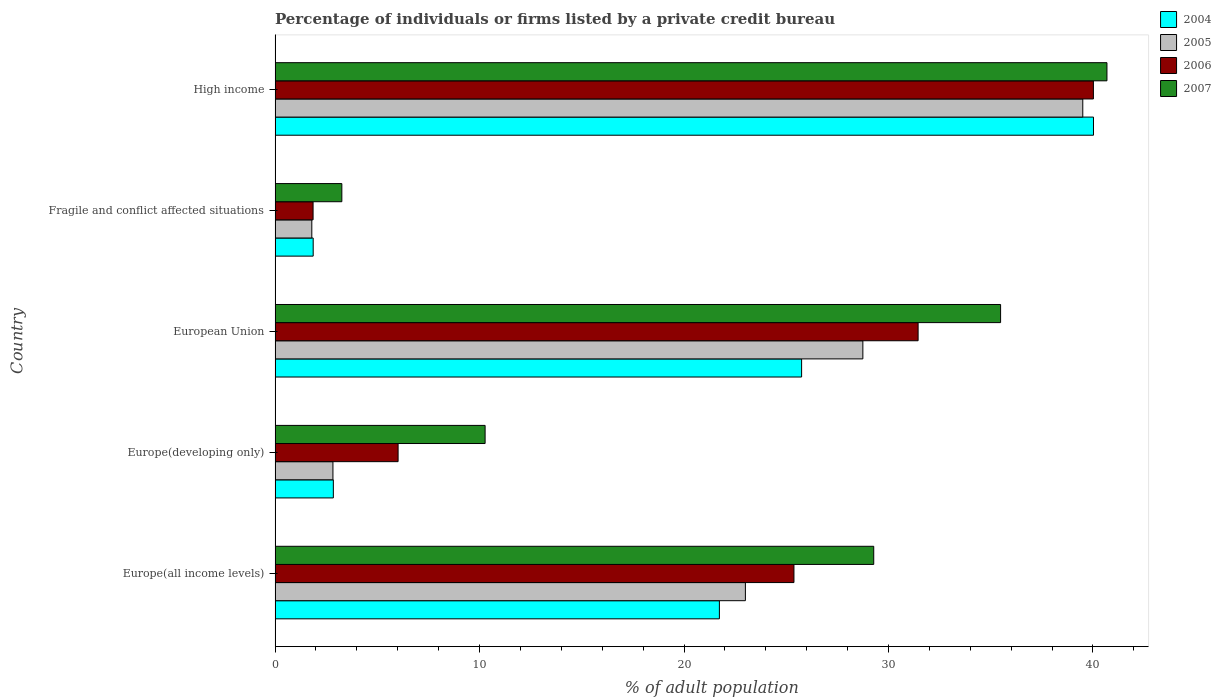Are the number of bars per tick equal to the number of legend labels?
Offer a very short reply. Yes. Are the number of bars on each tick of the Y-axis equal?
Offer a terse response. Yes. How many bars are there on the 5th tick from the bottom?
Provide a succinct answer. 4. In how many cases, is the number of bars for a given country not equal to the number of legend labels?
Your response must be concise. 0. What is the percentage of population listed by a private credit bureau in 2007 in European Union?
Your response must be concise. 35.48. Across all countries, what is the maximum percentage of population listed by a private credit bureau in 2006?
Offer a very short reply. 40.02. Across all countries, what is the minimum percentage of population listed by a private credit bureau in 2005?
Offer a very short reply. 1.8. In which country was the percentage of population listed by a private credit bureau in 2006 maximum?
Make the answer very short. High income. In which country was the percentage of population listed by a private credit bureau in 2004 minimum?
Keep it short and to the point. Fragile and conflict affected situations. What is the total percentage of population listed by a private credit bureau in 2004 in the graph?
Keep it short and to the point. 92.22. What is the difference between the percentage of population listed by a private credit bureau in 2005 in Europe(all income levels) and that in European Union?
Give a very brief answer. -5.75. What is the difference between the percentage of population listed by a private credit bureau in 2007 in Europe(developing only) and the percentage of population listed by a private credit bureau in 2005 in European Union?
Offer a very short reply. -18.48. What is the average percentage of population listed by a private credit bureau in 2004 per country?
Provide a succinct answer. 18.44. What is the difference between the percentage of population listed by a private credit bureau in 2004 and percentage of population listed by a private credit bureau in 2007 in Europe(all income levels)?
Make the answer very short. -7.55. In how many countries, is the percentage of population listed by a private credit bureau in 2004 greater than 18 %?
Offer a very short reply. 3. What is the ratio of the percentage of population listed by a private credit bureau in 2006 in Europe(developing only) to that in Fragile and conflict affected situations?
Your response must be concise. 3.24. What is the difference between the highest and the second highest percentage of population listed by a private credit bureau in 2006?
Ensure brevity in your answer.  8.57. What is the difference between the highest and the lowest percentage of population listed by a private credit bureau in 2006?
Offer a very short reply. 38.17. In how many countries, is the percentage of population listed by a private credit bureau in 2004 greater than the average percentage of population listed by a private credit bureau in 2004 taken over all countries?
Give a very brief answer. 3. Is the sum of the percentage of population listed by a private credit bureau in 2007 in Europe(all income levels) and Fragile and conflict affected situations greater than the maximum percentage of population listed by a private credit bureau in 2004 across all countries?
Your answer should be compact. No. What is the difference between two consecutive major ticks on the X-axis?
Give a very brief answer. 10. Does the graph contain grids?
Give a very brief answer. No. Where does the legend appear in the graph?
Make the answer very short. Top right. How many legend labels are there?
Your answer should be compact. 4. What is the title of the graph?
Provide a short and direct response. Percentage of individuals or firms listed by a private credit bureau. What is the label or title of the X-axis?
Ensure brevity in your answer.  % of adult population. What is the label or title of the Y-axis?
Your response must be concise. Country. What is the % of adult population of 2004 in Europe(all income levels)?
Make the answer very short. 21.73. What is the % of adult population of 2005 in Europe(all income levels)?
Make the answer very short. 23. What is the % of adult population of 2006 in Europe(all income levels)?
Give a very brief answer. 25.38. What is the % of adult population in 2007 in Europe(all income levels)?
Your answer should be compact. 29.28. What is the % of adult population of 2004 in Europe(developing only)?
Give a very brief answer. 2.85. What is the % of adult population in 2005 in Europe(developing only)?
Make the answer very short. 2.83. What is the % of adult population in 2006 in Europe(developing only)?
Offer a terse response. 6.02. What is the % of adult population of 2007 in Europe(developing only)?
Provide a succinct answer. 10.27. What is the % of adult population in 2004 in European Union?
Your answer should be compact. 25.75. What is the % of adult population of 2005 in European Union?
Provide a short and direct response. 28.75. What is the % of adult population of 2006 in European Union?
Ensure brevity in your answer.  31.45. What is the % of adult population in 2007 in European Union?
Keep it short and to the point. 35.48. What is the % of adult population of 2004 in Fragile and conflict affected situations?
Give a very brief answer. 1.86. What is the % of adult population in 2005 in Fragile and conflict affected situations?
Keep it short and to the point. 1.8. What is the % of adult population in 2006 in Fragile and conflict affected situations?
Your answer should be very brief. 1.86. What is the % of adult population of 2007 in Fragile and conflict affected situations?
Provide a short and direct response. 3.27. What is the % of adult population of 2004 in High income?
Make the answer very short. 40.03. What is the % of adult population of 2005 in High income?
Ensure brevity in your answer.  39.5. What is the % of adult population in 2006 in High income?
Offer a very short reply. 40.02. What is the % of adult population of 2007 in High income?
Give a very brief answer. 40.69. Across all countries, what is the maximum % of adult population in 2004?
Provide a succinct answer. 40.03. Across all countries, what is the maximum % of adult population in 2005?
Provide a short and direct response. 39.5. Across all countries, what is the maximum % of adult population in 2006?
Your answer should be very brief. 40.02. Across all countries, what is the maximum % of adult population in 2007?
Your response must be concise. 40.69. Across all countries, what is the minimum % of adult population of 2004?
Offer a terse response. 1.86. Across all countries, what is the minimum % of adult population of 2005?
Provide a succinct answer. 1.8. Across all countries, what is the minimum % of adult population in 2006?
Provide a short and direct response. 1.86. Across all countries, what is the minimum % of adult population of 2007?
Provide a short and direct response. 3.27. What is the total % of adult population in 2004 in the graph?
Keep it short and to the point. 92.22. What is the total % of adult population of 2005 in the graph?
Your answer should be compact. 95.88. What is the total % of adult population in 2006 in the graph?
Offer a terse response. 104.73. What is the total % of adult population in 2007 in the graph?
Provide a succinct answer. 118.99. What is the difference between the % of adult population in 2004 in Europe(all income levels) and that in Europe(developing only)?
Give a very brief answer. 18.88. What is the difference between the % of adult population of 2005 in Europe(all income levels) and that in Europe(developing only)?
Your response must be concise. 20.17. What is the difference between the % of adult population of 2006 in Europe(all income levels) and that in Europe(developing only)?
Keep it short and to the point. 19.36. What is the difference between the % of adult population in 2007 in Europe(all income levels) and that in Europe(developing only)?
Provide a succinct answer. 19.01. What is the difference between the % of adult population of 2004 in Europe(all income levels) and that in European Union?
Your answer should be compact. -4.02. What is the difference between the % of adult population of 2005 in Europe(all income levels) and that in European Union?
Provide a short and direct response. -5.75. What is the difference between the % of adult population in 2006 in Europe(all income levels) and that in European Union?
Your answer should be very brief. -6.07. What is the difference between the % of adult population in 2007 in Europe(all income levels) and that in European Union?
Offer a terse response. -6.2. What is the difference between the % of adult population of 2004 in Europe(all income levels) and that in Fragile and conflict affected situations?
Provide a short and direct response. 19.87. What is the difference between the % of adult population in 2005 in Europe(all income levels) and that in Fragile and conflict affected situations?
Your response must be concise. 21.21. What is the difference between the % of adult population in 2006 in Europe(all income levels) and that in Fragile and conflict affected situations?
Give a very brief answer. 23.52. What is the difference between the % of adult population in 2007 in Europe(all income levels) and that in Fragile and conflict affected situations?
Your response must be concise. 26.01. What is the difference between the % of adult population of 2004 in Europe(all income levels) and that in High income?
Make the answer very short. -18.3. What is the difference between the % of adult population in 2005 in Europe(all income levels) and that in High income?
Keep it short and to the point. -16.5. What is the difference between the % of adult population of 2006 in Europe(all income levels) and that in High income?
Offer a terse response. -14.65. What is the difference between the % of adult population of 2007 in Europe(all income levels) and that in High income?
Provide a succinct answer. -11.41. What is the difference between the % of adult population of 2004 in Europe(developing only) and that in European Union?
Your response must be concise. -22.9. What is the difference between the % of adult population of 2005 in Europe(developing only) and that in European Union?
Your answer should be compact. -25.92. What is the difference between the % of adult population of 2006 in Europe(developing only) and that in European Union?
Ensure brevity in your answer.  -25.43. What is the difference between the % of adult population in 2007 in Europe(developing only) and that in European Union?
Your answer should be compact. -25.21. What is the difference between the % of adult population of 2004 in Europe(developing only) and that in Fragile and conflict affected situations?
Your response must be concise. 0.99. What is the difference between the % of adult population in 2005 in Europe(developing only) and that in Fragile and conflict affected situations?
Provide a succinct answer. 1.03. What is the difference between the % of adult population in 2006 in Europe(developing only) and that in Fragile and conflict affected situations?
Make the answer very short. 4.16. What is the difference between the % of adult population in 2007 in Europe(developing only) and that in Fragile and conflict affected situations?
Ensure brevity in your answer.  7.01. What is the difference between the % of adult population of 2004 in Europe(developing only) and that in High income?
Your answer should be compact. -37.18. What is the difference between the % of adult population in 2005 in Europe(developing only) and that in High income?
Offer a very short reply. -36.67. What is the difference between the % of adult population of 2006 in Europe(developing only) and that in High income?
Offer a terse response. -34.01. What is the difference between the % of adult population of 2007 in Europe(developing only) and that in High income?
Provide a short and direct response. -30.41. What is the difference between the % of adult population of 2004 in European Union and that in Fragile and conflict affected situations?
Keep it short and to the point. 23.89. What is the difference between the % of adult population of 2005 in European Union and that in Fragile and conflict affected situations?
Your answer should be very brief. 26.95. What is the difference between the % of adult population in 2006 in European Union and that in Fragile and conflict affected situations?
Make the answer very short. 29.59. What is the difference between the % of adult population of 2007 in European Union and that in Fragile and conflict affected situations?
Make the answer very short. 32.22. What is the difference between the % of adult population in 2004 in European Union and that in High income?
Offer a very short reply. -14.28. What is the difference between the % of adult population in 2005 in European Union and that in High income?
Your answer should be compact. -10.76. What is the difference between the % of adult population in 2006 in European Union and that in High income?
Offer a very short reply. -8.57. What is the difference between the % of adult population of 2007 in European Union and that in High income?
Your answer should be compact. -5.2. What is the difference between the % of adult population in 2004 in Fragile and conflict affected situations and that in High income?
Keep it short and to the point. -38.16. What is the difference between the % of adult population of 2005 in Fragile and conflict affected situations and that in High income?
Your response must be concise. -37.71. What is the difference between the % of adult population in 2006 in Fragile and conflict affected situations and that in High income?
Provide a succinct answer. -38.17. What is the difference between the % of adult population of 2007 in Fragile and conflict affected situations and that in High income?
Your response must be concise. -37.42. What is the difference between the % of adult population of 2004 in Europe(all income levels) and the % of adult population of 2005 in Europe(developing only)?
Ensure brevity in your answer.  18.9. What is the difference between the % of adult population in 2004 in Europe(all income levels) and the % of adult population in 2006 in Europe(developing only)?
Your response must be concise. 15.71. What is the difference between the % of adult population of 2004 in Europe(all income levels) and the % of adult population of 2007 in Europe(developing only)?
Your answer should be compact. 11.46. What is the difference between the % of adult population in 2005 in Europe(all income levels) and the % of adult population in 2006 in Europe(developing only)?
Make the answer very short. 16.99. What is the difference between the % of adult population of 2005 in Europe(all income levels) and the % of adult population of 2007 in Europe(developing only)?
Offer a very short reply. 12.73. What is the difference between the % of adult population of 2006 in Europe(all income levels) and the % of adult population of 2007 in Europe(developing only)?
Provide a short and direct response. 15.11. What is the difference between the % of adult population in 2004 in Europe(all income levels) and the % of adult population in 2005 in European Union?
Offer a terse response. -7.02. What is the difference between the % of adult population in 2004 in Europe(all income levels) and the % of adult population in 2006 in European Union?
Your answer should be very brief. -9.72. What is the difference between the % of adult population of 2004 in Europe(all income levels) and the % of adult population of 2007 in European Union?
Keep it short and to the point. -13.75. What is the difference between the % of adult population of 2005 in Europe(all income levels) and the % of adult population of 2006 in European Union?
Give a very brief answer. -8.45. What is the difference between the % of adult population in 2005 in Europe(all income levels) and the % of adult population in 2007 in European Union?
Your answer should be very brief. -12.48. What is the difference between the % of adult population in 2006 in Europe(all income levels) and the % of adult population in 2007 in European Union?
Make the answer very short. -10.11. What is the difference between the % of adult population in 2004 in Europe(all income levels) and the % of adult population in 2005 in Fragile and conflict affected situations?
Your answer should be very brief. 19.93. What is the difference between the % of adult population of 2004 in Europe(all income levels) and the % of adult population of 2006 in Fragile and conflict affected situations?
Offer a terse response. 19.87. What is the difference between the % of adult population in 2004 in Europe(all income levels) and the % of adult population in 2007 in Fragile and conflict affected situations?
Give a very brief answer. 18.47. What is the difference between the % of adult population in 2005 in Europe(all income levels) and the % of adult population in 2006 in Fragile and conflict affected situations?
Ensure brevity in your answer.  21.14. What is the difference between the % of adult population in 2005 in Europe(all income levels) and the % of adult population in 2007 in Fragile and conflict affected situations?
Ensure brevity in your answer.  19.74. What is the difference between the % of adult population of 2006 in Europe(all income levels) and the % of adult population of 2007 in Fragile and conflict affected situations?
Offer a terse response. 22.11. What is the difference between the % of adult population in 2004 in Europe(all income levels) and the % of adult population in 2005 in High income?
Your answer should be very brief. -17.77. What is the difference between the % of adult population in 2004 in Europe(all income levels) and the % of adult population in 2006 in High income?
Ensure brevity in your answer.  -18.29. What is the difference between the % of adult population of 2004 in Europe(all income levels) and the % of adult population of 2007 in High income?
Your answer should be compact. -18.96. What is the difference between the % of adult population of 2005 in Europe(all income levels) and the % of adult population of 2006 in High income?
Provide a succinct answer. -17.02. What is the difference between the % of adult population of 2005 in Europe(all income levels) and the % of adult population of 2007 in High income?
Your answer should be compact. -17.68. What is the difference between the % of adult population of 2006 in Europe(all income levels) and the % of adult population of 2007 in High income?
Give a very brief answer. -15.31. What is the difference between the % of adult population in 2004 in Europe(developing only) and the % of adult population in 2005 in European Union?
Your response must be concise. -25.9. What is the difference between the % of adult population in 2004 in Europe(developing only) and the % of adult population in 2006 in European Union?
Offer a very short reply. -28.6. What is the difference between the % of adult population in 2004 in Europe(developing only) and the % of adult population in 2007 in European Union?
Your response must be concise. -32.63. What is the difference between the % of adult population of 2005 in Europe(developing only) and the % of adult population of 2006 in European Union?
Provide a short and direct response. -28.62. What is the difference between the % of adult population of 2005 in Europe(developing only) and the % of adult population of 2007 in European Union?
Your response must be concise. -32.66. What is the difference between the % of adult population of 2006 in Europe(developing only) and the % of adult population of 2007 in European Union?
Ensure brevity in your answer.  -29.47. What is the difference between the % of adult population of 2004 in Europe(developing only) and the % of adult population of 2005 in Fragile and conflict affected situations?
Ensure brevity in your answer.  1.05. What is the difference between the % of adult population in 2004 in Europe(developing only) and the % of adult population in 2006 in Fragile and conflict affected situations?
Your answer should be very brief. 0.99. What is the difference between the % of adult population of 2004 in Europe(developing only) and the % of adult population of 2007 in Fragile and conflict affected situations?
Your response must be concise. -0.42. What is the difference between the % of adult population in 2005 in Europe(developing only) and the % of adult population in 2006 in Fragile and conflict affected situations?
Ensure brevity in your answer.  0.97. What is the difference between the % of adult population of 2005 in Europe(developing only) and the % of adult population of 2007 in Fragile and conflict affected situations?
Your response must be concise. -0.44. What is the difference between the % of adult population in 2006 in Europe(developing only) and the % of adult population in 2007 in Fragile and conflict affected situations?
Make the answer very short. 2.75. What is the difference between the % of adult population of 2004 in Europe(developing only) and the % of adult population of 2005 in High income?
Give a very brief answer. -36.65. What is the difference between the % of adult population in 2004 in Europe(developing only) and the % of adult population in 2006 in High income?
Your answer should be very brief. -37.17. What is the difference between the % of adult population of 2004 in Europe(developing only) and the % of adult population of 2007 in High income?
Your response must be concise. -37.84. What is the difference between the % of adult population of 2005 in Europe(developing only) and the % of adult population of 2006 in High income?
Offer a very short reply. -37.19. What is the difference between the % of adult population of 2005 in Europe(developing only) and the % of adult population of 2007 in High income?
Your answer should be very brief. -37.86. What is the difference between the % of adult population in 2006 in Europe(developing only) and the % of adult population in 2007 in High income?
Make the answer very short. -34.67. What is the difference between the % of adult population in 2004 in European Union and the % of adult population in 2005 in Fragile and conflict affected situations?
Keep it short and to the point. 23.96. What is the difference between the % of adult population of 2004 in European Union and the % of adult population of 2006 in Fragile and conflict affected situations?
Provide a short and direct response. 23.89. What is the difference between the % of adult population in 2004 in European Union and the % of adult population in 2007 in Fragile and conflict affected situations?
Provide a short and direct response. 22.49. What is the difference between the % of adult population in 2005 in European Union and the % of adult population in 2006 in Fragile and conflict affected situations?
Your answer should be compact. 26.89. What is the difference between the % of adult population of 2005 in European Union and the % of adult population of 2007 in Fragile and conflict affected situations?
Provide a short and direct response. 25.48. What is the difference between the % of adult population of 2006 in European Union and the % of adult population of 2007 in Fragile and conflict affected situations?
Your response must be concise. 28.18. What is the difference between the % of adult population in 2004 in European Union and the % of adult population in 2005 in High income?
Offer a very short reply. -13.75. What is the difference between the % of adult population in 2004 in European Union and the % of adult population in 2006 in High income?
Your response must be concise. -14.27. What is the difference between the % of adult population in 2004 in European Union and the % of adult population in 2007 in High income?
Give a very brief answer. -14.93. What is the difference between the % of adult population of 2005 in European Union and the % of adult population of 2006 in High income?
Provide a short and direct response. -11.28. What is the difference between the % of adult population of 2005 in European Union and the % of adult population of 2007 in High income?
Make the answer very short. -11.94. What is the difference between the % of adult population of 2006 in European Union and the % of adult population of 2007 in High income?
Provide a succinct answer. -9.24. What is the difference between the % of adult population in 2004 in Fragile and conflict affected situations and the % of adult population in 2005 in High income?
Your answer should be compact. -37.64. What is the difference between the % of adult population of 2004 in Fragile and conflict affected situations and the % of adult population of 2006 in High income?
Keep it short and to the point. -38.16. What is the difference between the % of adult population in 2004 in Fragile and conflict affected situations and the % of adult population in 2007 in High income?
Give a very brief answer. -38.82. What is the difference between the % of adult population in 2005 in Fragile and conflict affected situations and the % of adult population in 2006 in High income?
Give a very brief answer. -38.23. What is the difference between the % of adult population of 2005 in Fragile and conflict affected situations and the % of adult population of 2007 in High income?
Provide a succinct answer. -38.89. What is the difference between the % of adult population of 2006 in Fragile and conflict affected situations and the % of adult population of 2007 in High income?
Make the answer very short. -38.83. What is the average % of adult population in 2004 per country?
Your answer should be very brief. 18.45. What is the average % of adult population of 2005 per country?
Make the answer very short. 19.18. What is the average % of adult population in 2006 per country?
Give a very brief answer. 20.95. What is the average % of adult population of 2007 per country?
Keep it short and to the point. 23.8. What is the difference between the % of adult population of 2004 and % of adult population of 2005 in Europe(all income levels)?
Give a very brief answer. -1.27. What is the difference between the % of adult population of 2004 and % of adult population of 2006 in Europe(all income levels)?
Provide a short and direct response. -3.65. What is the difference between the % of adult population in 2004 and % of adult population in 2007 in Europe(all income levels)?
Your response must be concise. -7.55. What is the difference between the % of adult population in 2005 and % of adult population in 2006 in Europe(all income levels)?
Make the answer very short. -2.38. What is the difference between the % of adult population in 2005 and % of adult population in 2007 in Europe(all income levels)?
Provide a succinct answer. -6.28. What is the difference between the % of adult population of 2006 and % of adult population of 2007 in Europe(all income levels)?
Ensure brevity in your answer.  -3.9. What is the difference between the % of adult population in 2004 and % of adult population in 2005 in Europe(developing only)?
Your answer should be compact. 0.02. What is the difference between the % of adult population of 2004 and % of adult population of 2006 in Europe(developing only)?
Your response must be concise. -3.17. What is the difference between the % of adult population of 2004 and % of adult population of 2007 in Europe(developing only)?
Give a very brief answer. -7.42. What is the difference between the % of adult population of 2005 and % of adult population of 2006 in Europe(developing only)?
Offer a terse response. -3.19. What is the difference between the % of adult population of 2005 and % of adult population of 2007 in Europe(developing only)?
Your response must be concise. -7.44. What is the difference between the % of adult population of 2006 and % of adult population of 2007 in Europe(developing only)?
Provide a short and direct response. -4.26. What is the difference between the % of adult population in 2004 and % of adult population in 2005 in European Union?
Provide a short and direct response. -3. What is the difference between the % of adult population in 2004 and % of adult population in 2006 in European Union?
Keep it short and to the point. -5.7. What is the difference between the % of adult population of 2004 and % of adult population of 2007 in European Union?
Offer a very short reply. -9.73. What is the difference between the % of adult population in 2005 and % of adult population in 2006 in European Union?
Your response must be concise. -2.7. What is the difference between the % of adult population in 2005 and % of adult population in 2007 in European Union?
Keep it short and to the point. -6.74. What is the difference between the % of adult population of 2006 and % of adult population of 2007 in European Union?
Offer a terse response. -4.03. What is the difference between the % of adult population in 2004 and % of adult population in 2005 in Fragile and conflict affected situations?
Your answer should be very brief. 0.07. What is the difference between the % of adult population in 2004 and % of adult population in 2006 in Fragile and conflict affected situations?
Provide a short and direct response. 0.01. What is the difference between the % of adult population of 2004 and % of adult population of 2007 in Fragile and conflict affected situations?
Your answer should be very brief. -1.4. What is the difference between the % of adult population in 2005 and % of adult population in 2006 in Fragile and conflict affected situations?
Ensure brevity in your answer.  -0.06. What is the difference between the % of adult population of 2005 and % of adult population of 2007 in Fragile and conflict affected situations?
Your answer should be compact. -1.47. What is the difference between the % of adult population in 2006 and % of adult population in 2007 in Fragile and conflict affected situations?
Offer a terse response. -1.41. What is the difference between the % of adult population of 2004 and % of adult population of 2005 in High income?
Offer a very short reply. 0.52. What is the difference between the % of adult population of 2004 and % of adult population of 2006 in High income?
Give a very brief answer. 0. What is the difference between the % of adult population in 2004 and % of adult population in 2007 in High income?
Your response must be concise. -0.66. What is the difference between the % of adult population in 2005 and % of adult population in 2006 in High income?
Offer a terse response. -0.52. What is the difference between the % of adult population of 2005 and % of adult population of 2007 in High income?
Make the answer very short. -1.18. What is the difference between the % of adult population of 2006 and % of adult population of 2007 in High income?
Your answer should be very brief. -0.66. What is the ratio of the % of adult population of 2004 in Europe(all income levels) to that in Europe(developing only)?
Provide a short and direct response. 7.62. What is the ratio of the % of adult population in 2005 in Europe(all income levels) to that in Europe(developing only)?
Provide a succinct answer. 8.13. What is the ratio of the % of adult population of 2006 in Europe(all income levels) to that in Europe(developing only)?
Offer a terse response. 4.22. What is the ratio of the % of adult population of 2007 in Europe(all income levels) to that in Europe(developing only)?
Ensure brevity in your answer.  2.85. What is the ratio of the % of adult population in 2004 in Europe(all income levels) to that in European Union?
Ensure brevity in your answer.  0.84. What is the ratio of the % of adult population of 2005 in Europe(all income levels) to that in European Union?
Provide a succinct answer. 0.8. What is the ratio of the % of adult population of 2006 in Europe(all income levels) to that in European Union?
Give a very brief answer. 0.81. What is the ratio of the % of adult population in 2007 in Europe(all income levels) to that in European Union?
Give a very brief answer. 0.83. What is the ratio of the % of adult population of 2004 in Europe(all income levels) to that in Fragile and conflict affected situations?
Provide a short and direct response. 11.66. What is the ratio of the % of adult population of 2005 in Europe(all income levels) to that in Fragile and conflict affected situations?
Your response must be concise. 12.8. What is the ratio of the % of adult population of 2006 in Europe(all income levels) to that in Fragile and conflict affected situations?
Provide a short and direct response. 13.65. What is the ratio of the % of adult population of 2007 in Europe(all income levels) to that in Fragile and conflict affected situations?
Your answer should be very brief. 8.97. What is the ratio of the % of adult population in 2004 in Europe(all income levels) to that in High income?
Keep it short and to the point. 0.54. What is the ratio of the % of adult population of 2005 in Europe(all income levels) to that in High income?
Provide a succinct answer. 0.58. What is the ratio of the % of adult population of 2006 in Europe(all income levels) to that in High income?
Provide a short and direct response. 0.63. What is the ratio of the % of adult population in 2007 in Europe(all income levels) to that in High income?
Keep it short and to the point. 0.72. What is the ratio of the % of adult population of 2004 in Europe(developing only) to that in European Union?
Your response must be concise. 0.11. What is the ratio of the % of adult population of 2005 in Europe(developing only) to that in European Union?
Ensure brevity in your answer.  0.1. What is the ratio of the % of adult population in 2006 in Europe(developing only) to that in European Union?
Keep it short and to the point. 0.19. What is the ratio of the % of adult population in 2007 in Europe(developing only) to that in European Union?
Your answer should be compact. 0.29. What is the ratio of the % of adult population in 2004 in Europe(developing only) to that in Fragile and conflict affected situations?
Provide a succinct answer. 1.53. What is the ratio of the % of adult population of 2005 in Europe(developing only) to that in Fragile and conflict affected situations?
Offer a terse response. 1.57. What is the ratio of the % of adult population of 2006 in Europe(developing only) to that in Fragile and conflict affected situations?
Give a very brief answer. 3.24. What is the ratio of the % of adult population in 2007 in Europe(developing only) to that in Fragile and conflict affected situations?
Provide a succinct answer. 3.15. What is the ratio of the % of adult population in 2004 in Europe(developing only) to that in High income?
Your answer should be compact. 0.07. What is the ratio of the % of adult population in 2005 in Europe(developing only) to that in High income?
Give a very brief answer. 0.07. What is the ratio of the % of adult population in 2006 in Europe(developing only) to that in High income?
Provide a succinct answer. 0.15. What is the ratio of the % of adult population in 2007 in Europe(developing only) to that in High income?
Offer a very short reply. 0.25. What is the ratio of the % of adult population in 2004 in European Union to that in Fragile and conflict affected situations?
Provide a short and direct response. 13.82. What is the ratio of the % of adult population in 2005 in European Union to that in Fragile and conflict affected situations?
Ensure brevity in your answer.  16. What is the ratio of the % of adult population of 2006 in European Union to that in Fragile and conflict affected situations?
Your answer should be compact. 16.92. What is the ratio of the % of adult population in 2007 in European Union to that in Fragile and conflict affected situations?
Your answer should be compact. 10.87. What is the ratio of the % of adult population in 2004 in European Union to that in High income?
Make the answer very short. 0.64. What is the ratio of the % of adult population of 2005 in European Union to that in High income?
Your response must be concise. 0.73. What is the ratio of the % of adult population in 2006 in European Union to that in High income?
Keep it short and to the point. 0.79. What is the ratio of the % of adult population in 2007 in European Union to that in High income?
Your answer should be very brief. 0.87. What is the ratio of the % of adult population of 2004 in Fragile and conflict affected situations to that in High income?
Your answer should be compact. 0.05. What is the ratio of the % of adult population in 2005 in Fragile and conflict affected situations to that in High income?
Your answer should be very brief. 0.05. What is the ratio of the % of adult population in 2006 in Fragile and conflict affected situations to that in High income?
Make the answer very short. 0.05. What is the ratio of the % of adult population in 2007 in Fragile and conflict affected situations to that in High income?
Keep it short and to the point. 0.08. What is the difference between the highest and the second highest % of adult population of 2004?
Provide a succinct answer. 14.28. What is the difference between the highest and the second highest % of adult population of 2005?
Offer a terse response. 10.76. What is the difference between the highest and the second highest % of adult population in 2006?
Your answer should be very brief. 8.57. What is the difference between the highest and the second highest % of adult population in 2007?
Your answer should be compact. 5.2. What is the difference between the highest and the lowest % of adult population in 2004?
Your answer should be very brief. 38.16. What is the difference between the highest and the lowest % of adult population in 2005?
Offer a terse response. 37.71. What is the difference between the highest and the lowest % of adult population of 2006?
Your answer should be compact. 38.17. What is the difference between the highest and the lowest % of adult population of 2007?
Give a very brief answer. 37.42. 